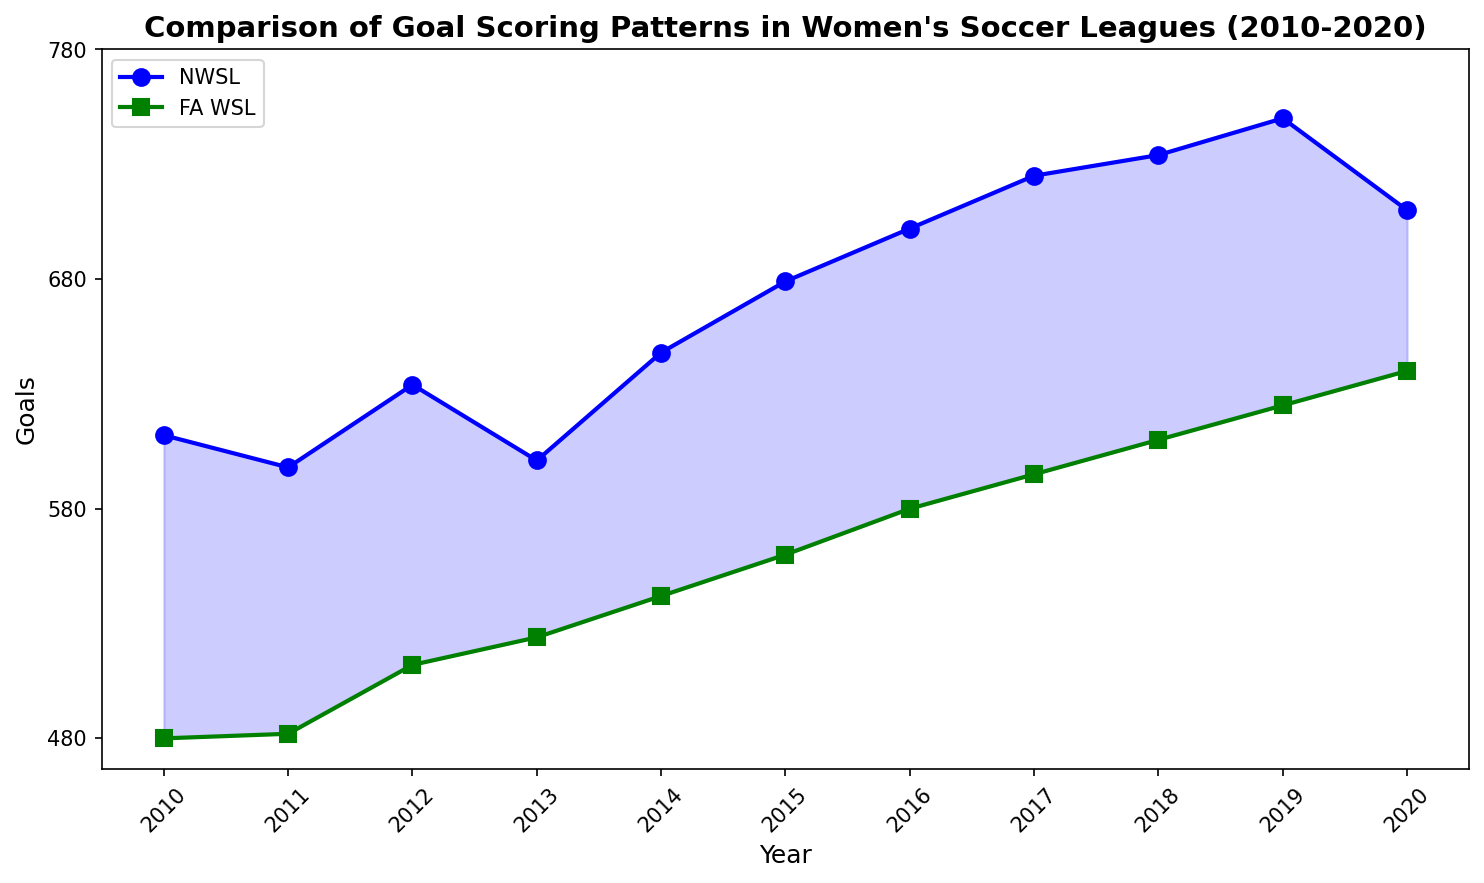What's the difference in goals between NWSL and FA WSL in 2015? Look at the values for both leagues in 2015: NWSL has 679 goals and FA WSL has 560 goals. Subtract the goals of FA WSL from NWSL: 679 - 560.
Answer: 119 Between 2010 and 2020, in which year did the FA WSL have the highest number of goals scored? Look at the data points for FA WSL from 2010 to 2020 and identify the maximum value: FA WSL scores range from 480 to 640, with the highest being 640 in 2020.
Answer: 2020 What was the total number of goals scored by NWSL over the entire period? Sum the goals for NWSL from 2010 to 2020: 
612 + 598 + 634 + 601 + 648 + 679 + 702 + 725 + 734 + 750 + 710 = 7393
Answer: 7393 What is the average number of goals scored per year in the FA WSL from 2010 to 2020? Sum the goals for FA WSL from 2010 to 2020 and then divide by the number of years (11):
480 + 482 + 512 + 524 + 542 + 560 + 580 + 595 + 610 + 625 + 640 = 6150
Average = 6150 / 11 = 559.09
Answer: 559.09 